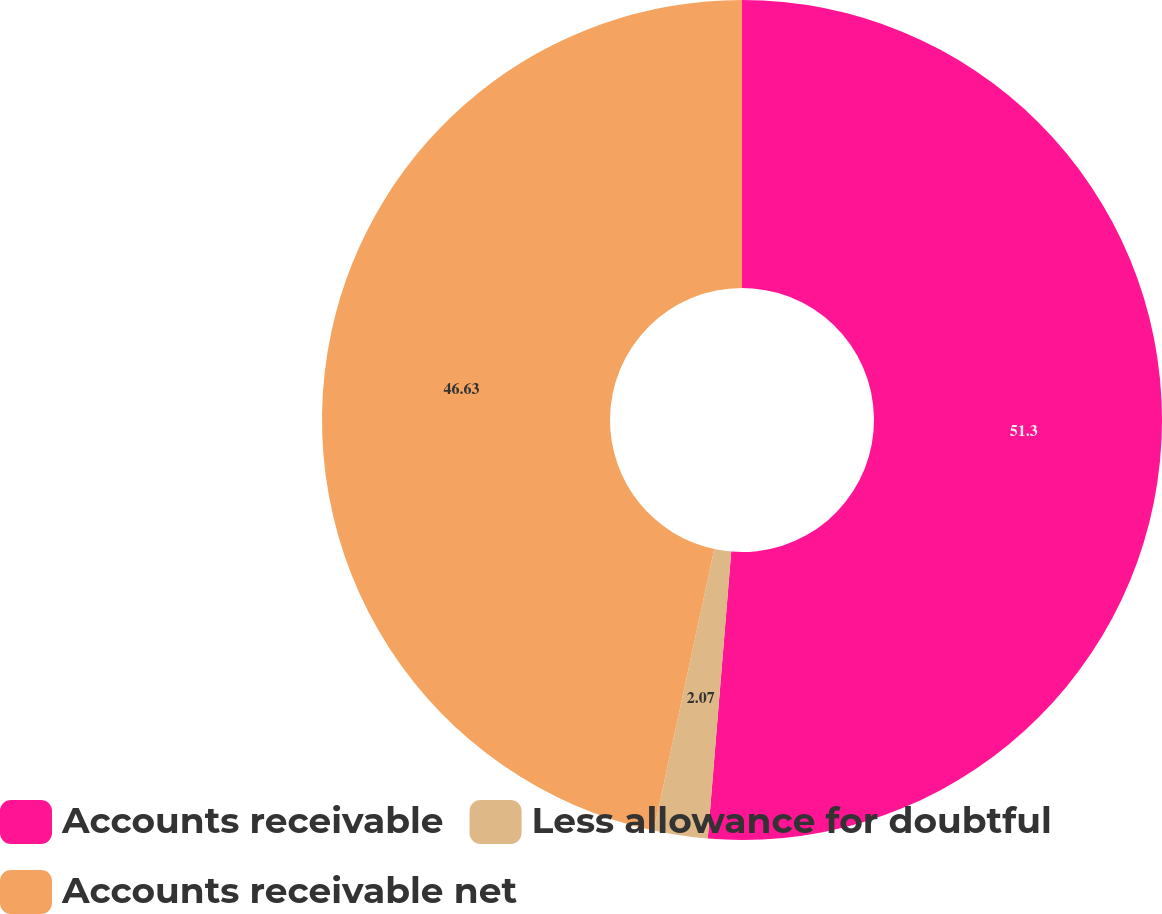<chart> <loc_0><loc_0><loc_500><loc_500><pie_chart><fcel>Accounts receivable<fcel>Less allowance for doubtful<fcel>Accounts receivable net<nl><fcel>51.3%<fcel>2.07%<fcel>46.63%<nl></chart> 